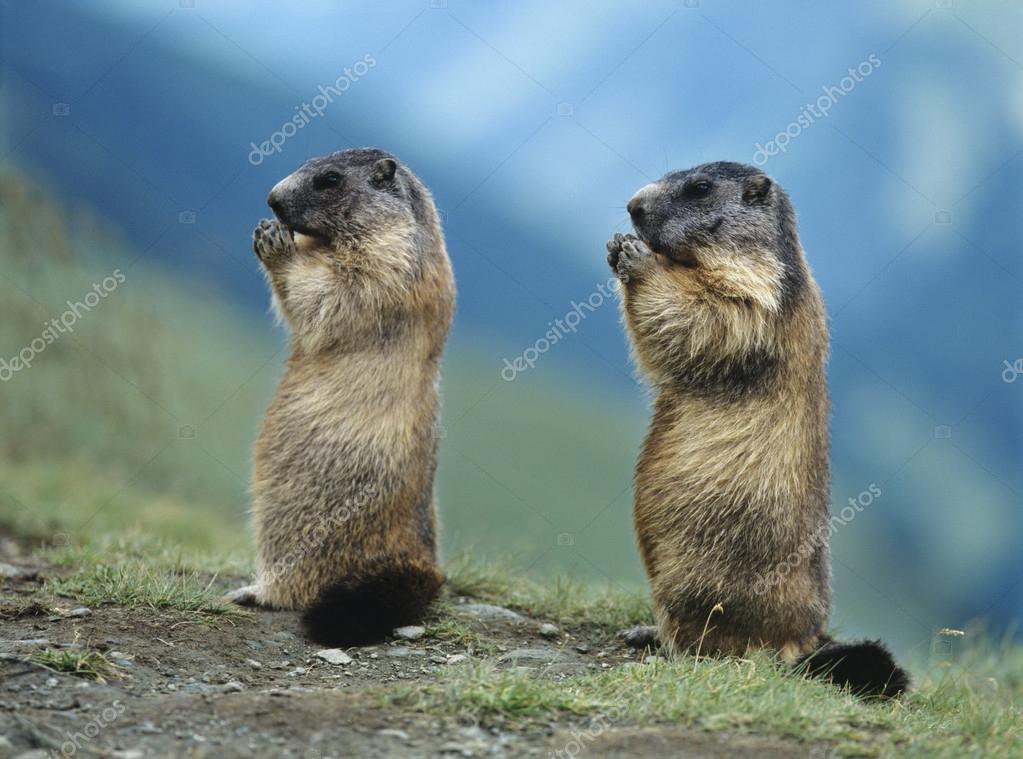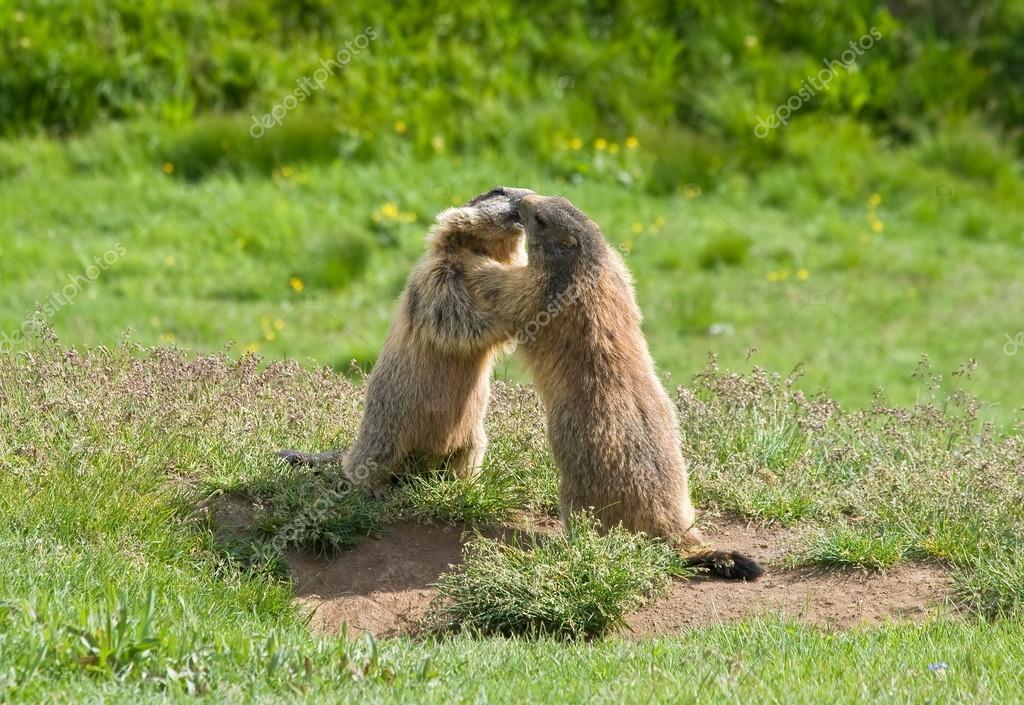The first image is the image on the left, the second image is the image on the right. Analyze the images presented: Is the assertion "An image shows two similarly-posed upright marmots, each facing leftward." valid? Answer yes or no. Yes. The first image is the image on the left, the second image is the image on the right. Given the left and right images, does the statement "In one of the images, there are two animals facing left." hold true? Answer yes or no. Yes. 